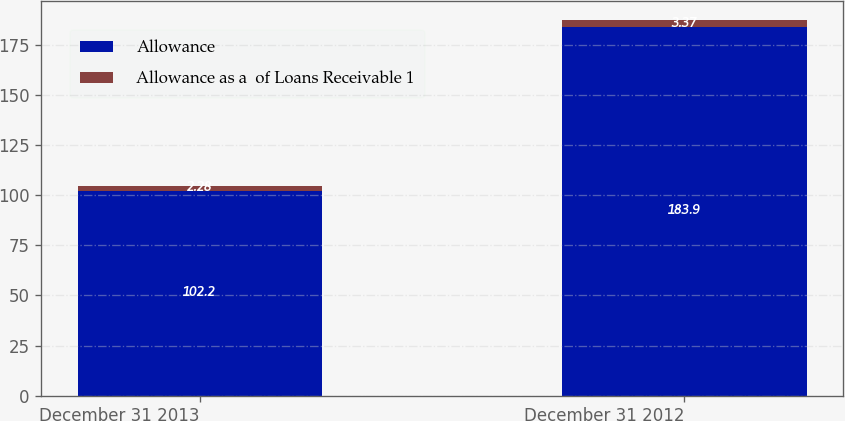<chart> <loc_0><loc_0><loc_500><loc_500><stacked_bar_chart><ecel><fcel>December 31 2013<fcel>December 31 2012<nl><fcel>Allowance<fcel>102.2<fcel>183.9<nl><fcel>Allowance as a  of Loans Receivable 1<fcel>2.28<fcel>3.37<nl></chart> 